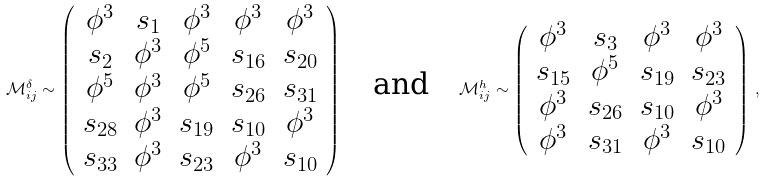Convert formula to latex. <formula><loc_0><loc_0><loc_500><loc_500>\mathcal { M } ^ { \delta } _ { i j } \sim \left ( \begin{array} { c c c c c } \phi ^ { 3 } & s _ { 1 } & \phi ^ { 3 } & \phi ^ { 3 } & \phi ^ { 3 } \\ s _ { 2 } & \phi ^ { 3 } & \phi ^ { 5 } & s _ { 1 6 } & s _ { 2 0 } \\ \phi ^ { 5 } & \phi ^ { 3 } & \phi ^ { 5 } & s _ { 2 6 } & s _ { 3 1 } \\ s _ { 2 8 } & \phi ^ { 3 } & s _ { 1 9 } & s _ { 1 0 } & \phi ^ { 3 } \\ s _ { 3 3 } & \phi ^ { 3 } & s _ { 2 3 } & \phi ^ { 3 } & s _ { 1 0 } \\ \end{array} \right ) \quad \text {and} \quad \mathcal { M } ^ { h } _ { i j } \sim \left ( \begin{array} { c c c c } \phi ^ { 3 } & s _ { 3 } & \phi ^ { 3 } & \phi ^ { 3 } \\ s _ { 1 5 } & \phi ^ { 5 } & s _ { 1 9 } & s _ { 2 3 } \\ \phi ^ { 3 } & s _ { 2 6 } & s _ { 1 0 } & \phi ^ { 3 } \\ \phi ^ { 3 } & s _ { 3 1 } & \phi ^ { 3 } & s _ { 1 0 } \\ \end{array} \right ) \, ,</formula> 